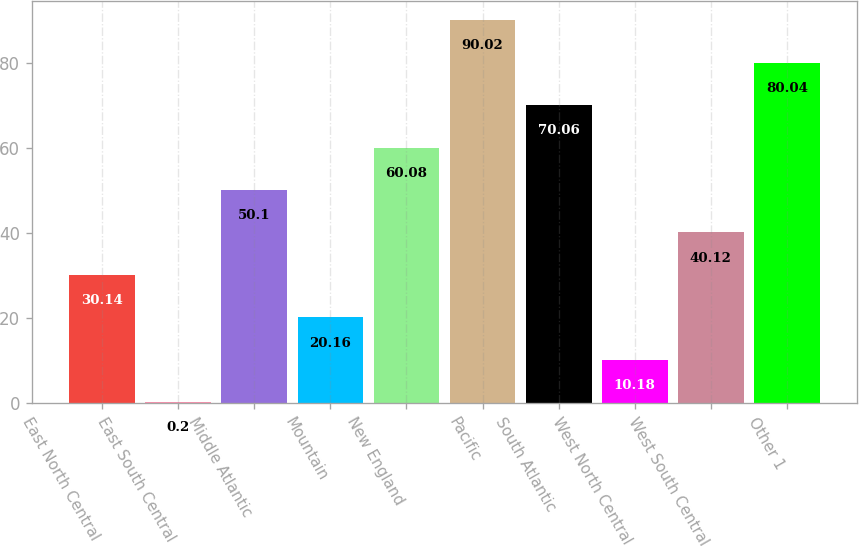<chart> <loc_0><loc_0><loc_500><loc_500><bar_chart><fcel>East North Central<fcel>East South Central<fcel>Middle Atlantic<fcel>Mountain<fcel>New England<fcel>Pacific<fcel>South Atlantic<fcel>West North Central<fcel>West South Central<fcel>Other 1<nl><fcel>30.14<fcel>0.2<fcel>50.1<fcel>20.16<fcel>60.08<fcel>90.02<fcel>70.06<fcel>10.18<fcel>40.12<fcel>80.04<nl></chart> 